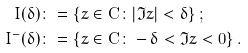Convert formula to latex. <formula><loc_0><loc_0><loc_500><loc_500>I ( \delta ) & \colon = \{ z \in { \mathbf C } \colon | \Im z | < \delta \} \, ; \\ I ^ { - } ( \delta ) & \colon = \{ z \in { \mathbf C } \colon - \delta < \Im z < 0 \} \, .</formula> 